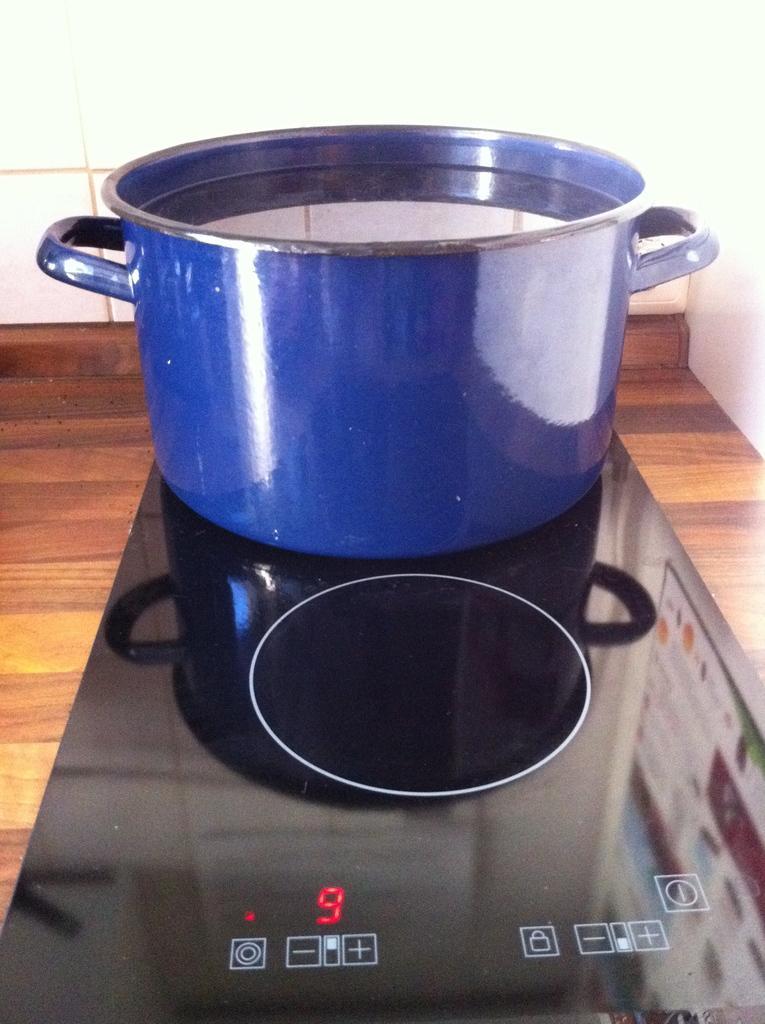Provide a one-sentence caption for the provided image. A blue pot full of water sitting on a stove burner that is set to 9. 